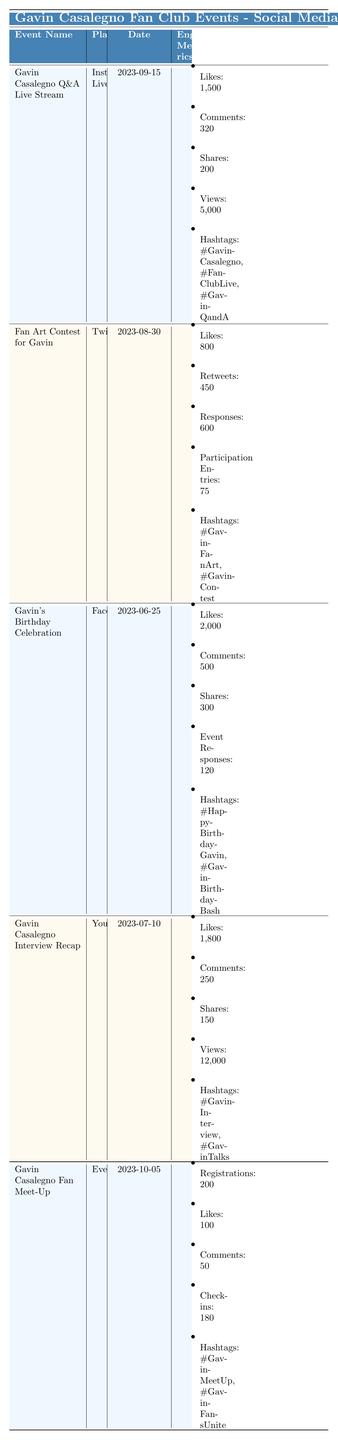What is the platform for Gavin's Birthday Celebration? The table specifies that the platform used for Gavin's Birthday Celebration was Facebook.
Answer: Facebook How many likes did the Fan Art Contest for Gavin receive? According to the table, the Fan Art Contest for Gavin received 800 likes.
Answer: 800 Which event had the highest number of shares? By reviewing the shares for each event in the table, Gavin's Birthday Celebration had the highest shares with a total of 300.
Answer: 300 What is the total number of comments across all events? The table provides comments for each event: 320 (Q&A), 600 (Fan Art Contest), 500 (Birthday Celebration), 250 (Interview Recap), and 50 (Fan Meet-Up). Adding these together: 320 + 600 + 500 + 250 + 50 = 1720.
Answer: 1720 Did the Gavin Casalegno Fan Meet-Up receive more likes than views from the Gavin Casalegno Interview Recap? The likes for the Fan Meet-Up were 100, whereas the Interview Recap had 12,000 views, so it is true that the Meet-Up received fewer likes than the views from the Recap.
Answer: No What is the average number of likes across all events? The total number of likes is calculated by adding: 1500 (Q&A) + 800 (Fan Art Contest) + 2000 (Birthday Celebration) + 1800 (Interview Recap) + 100 (Fan Meet-Up) = 5200. Since there are 5 events, the average likes are 5200 / 5 = 1040.
Answer: 1040 How many more views did the Gavin Casalegno Interview Recap have compared to the Q&A Live Stream? The Interview Recap had 12,000 views and the Q&A Live Stream had 5,000 views, making the difference: 12,000 - 5,000 = 7,000 views more for the Recap.
Answer: 7000 Which event had the most registrations? The only event with registration data in the table is the Fan Meet-Up, which had 200 registrations, indicating this was the highest.
Answer: 200 